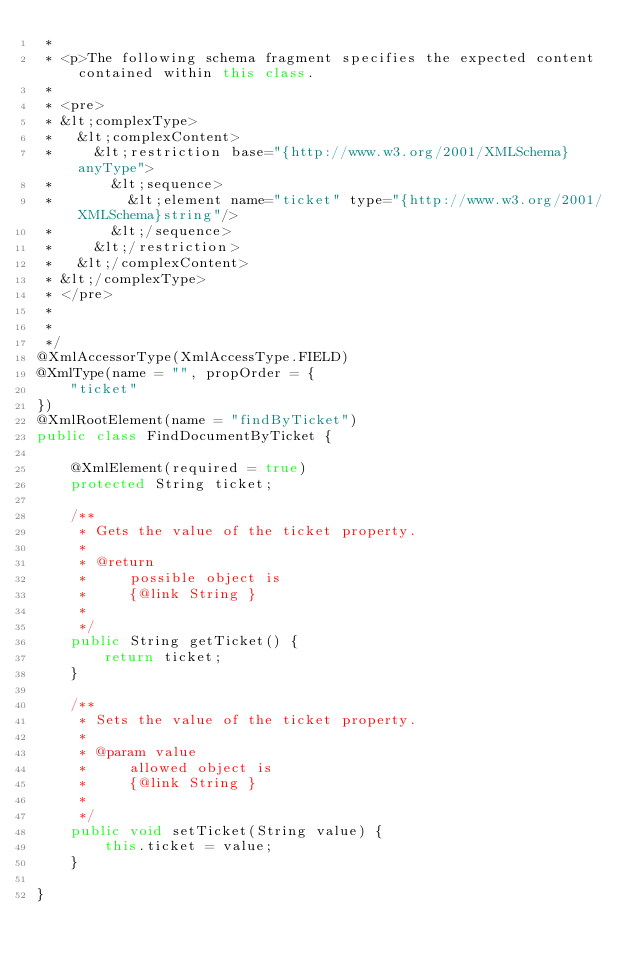<code> <loc_0><loc_0><loc_500><loc_500><_Java_> * 
 * <p>The following schema fragment specifies the expected content contained within this class.
 * 
 * <pre>
 * &lt;complexType>
 *   &lt;complexContent>
 *     &lt;restriction base="{http://www.w3.org/2001/XMLSchema}anyType">
 *       &lt;sequence>
 *         &lt;element name="ticket" type="{http://www.w3.org/2001/XMLSchema}string"/>
 *       &lt;/sequence>
 *     &lt;/restriction>
 *   &lt;/complexContent>
 * &lt;/complexType>
 * </pre>
 * 
 * 
 */
@XmlAccessorType(XmlAccessType.FIELD)
@XmlType(name = "", propOrder = {
    "ticket"
})
@XmlRootElement(name = "findByTicket")
public class FindDocumentByTicket {

    @XmlElement(required = true)
    protected String ticket;

    /**
     * Gets the value of the ticket property.
     * 
     * @return
     *     possible object is
     *     {@link String }
     *     
     */
    public String getTicket() {
        return ticket;
    }

    /**
     * Sets the value of the ticket property.
     * 
     * @param value
     *     allowed object is
     *     {@link String }
     *     
     */
    public void setTicket(String value) {
        this.ticket = value;
    }

}
</code> 